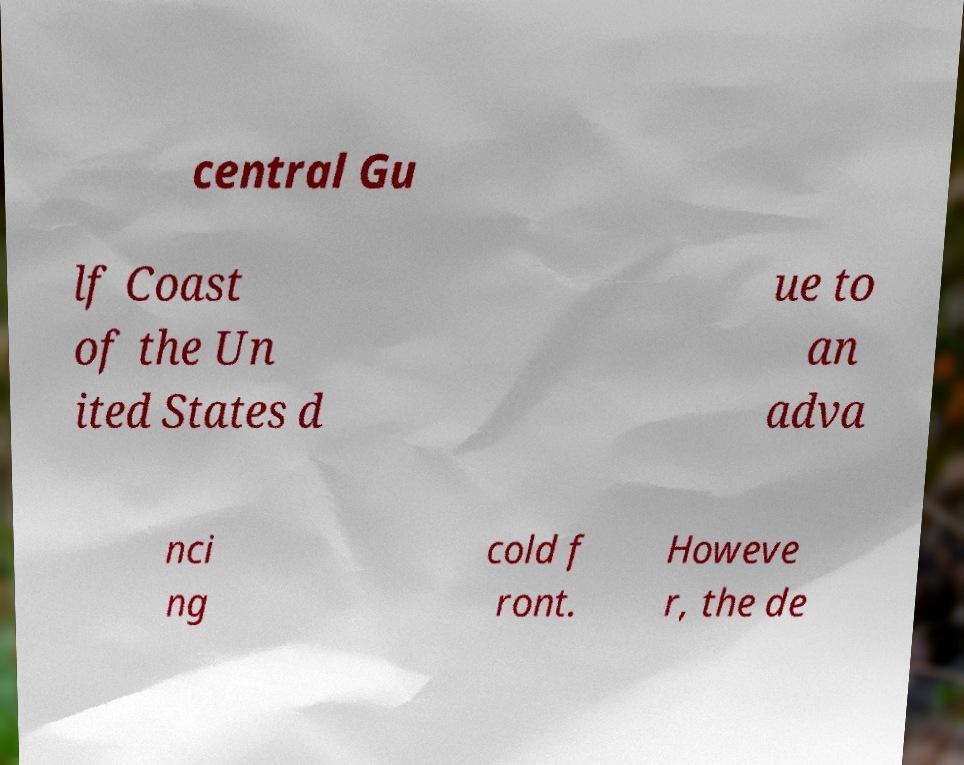Please read and relay the text visible in this image. What does it say? central Gu lf Coast of the Un ited States d ue to an adva nci ng cold f ront. Howeve r, the de 